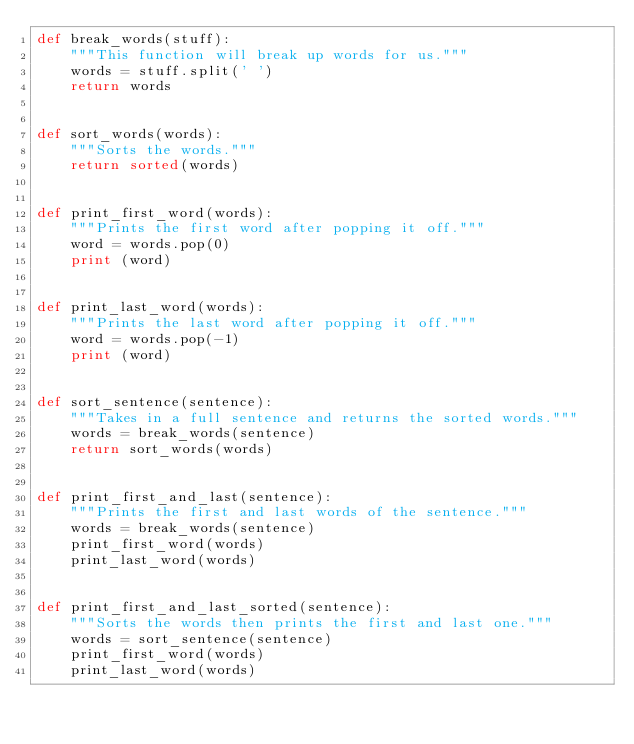Convert code to text. <code><loc_0><loc_0><loc_500><loc_500><_Python_>def break_words(stuff):
    """This function will break up words for us."""
    words = stuff.split(' ')
    return words


def sort_words(words):
    """Sorts the words."""
    return sorted(words)


def print_first_word(words):
    """Prints the first word after popping it off."""
    word = words.pop(0)
    print (word)


def print_last_word(words):
    """Prints the last word after popping it off."""
    word = words.pop(-1)
    print (word)


def sort_sentence(sentence):
    """Takes in a full sentence and returns the sorted words."""
    words = break_words(sentence)
    return sort_words(words)


def print_first_and_last(sentence):
    """Prints the first and last words of the sentence."""
    words = break_words(sentence)
    print_first_word(words)
    print_last_word(words)


def print_first_and_last_sorted(sentence):
    """Sorts the words then prints the first and last one."""
    words = sort_sentence(sentence)
    print_first_word(words)
    print_last_word(words)</code> 